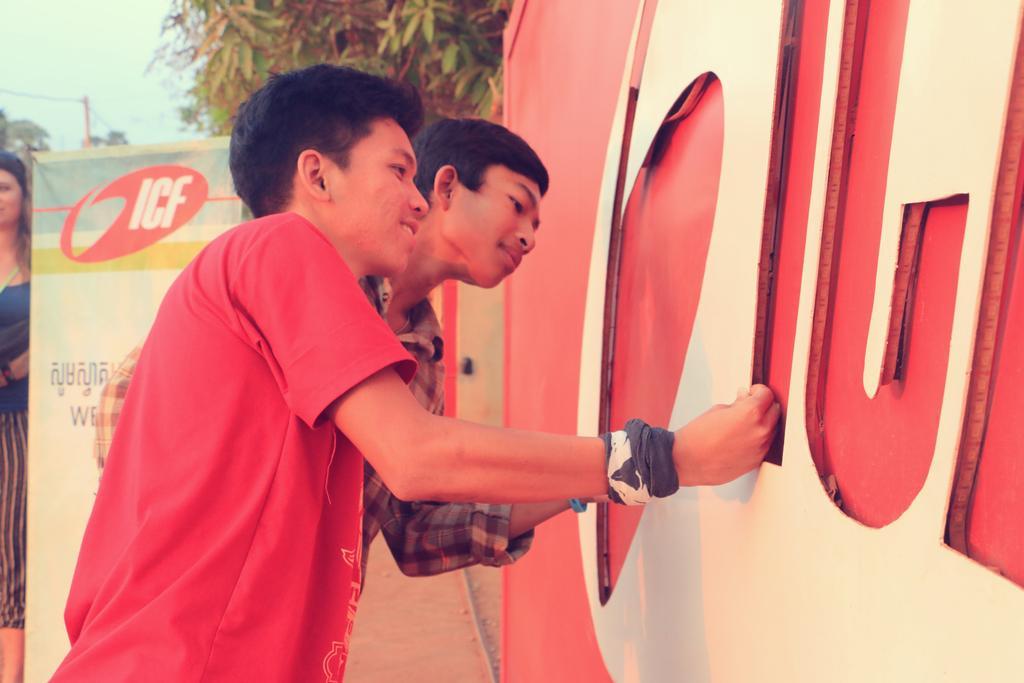Could you give a brief overview of what you see in this image? In this image I can see two person standing. In front the person is wearing red color shirt and I can also see the board in red and white color. In the background I can see the person standing, the banner in white color, few trees in green color and the sky is in white and blue color. 